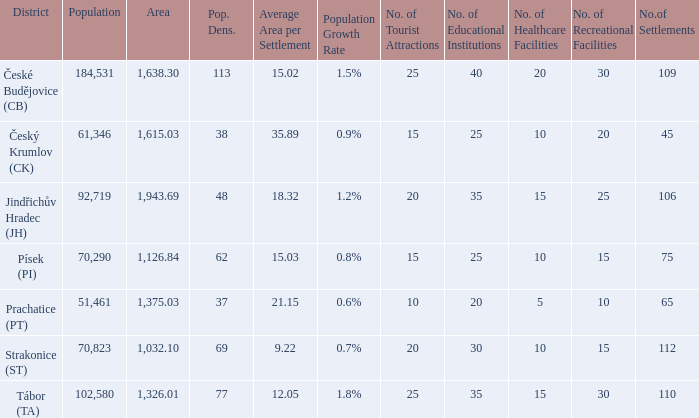What is the lowest population density of Strakonice (st) with more than 112 settlements? None. 